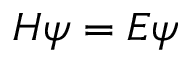<formula> <loc_0><loc_0><loc_500><loc_500>H \psi = E \psi</formula> 